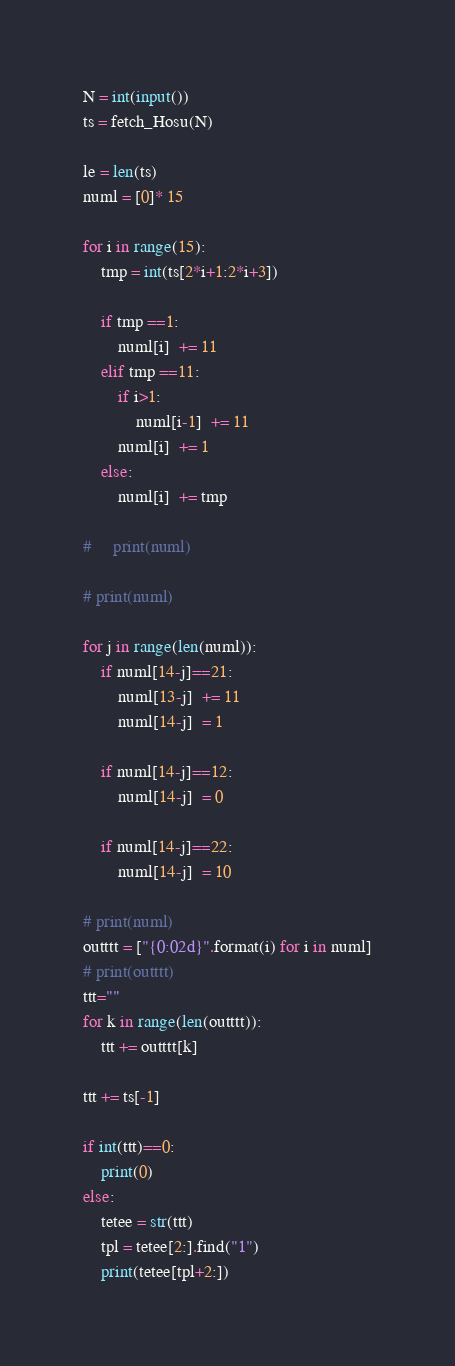<code> <loc_0><loc_0><loc_500><loc_500><_Python_>N = int(input())
ts = fetch_Hosu(N)

le = len(ts)
numl = [0]* 15

for i in range(15):
    tmp = int(ts[2*i+1:2*i+3])
    
    if tmp ==1:
        numl[i]  += 11
    elif tmp ==11:
        if i>1:
            numl[i-1]  += 11
        numl[i]  += 1
    else:
        numl[i]  += tmp
    
#     print(numl)

# print(numl)

for j in range(len(numl)):
    if numl[14-j]==21:
        numl[13-j]  += 11
        numl[14-j]  = 1

    if numl[14-j]==12:
        numl[14-j]  = 0
    
    if numl[14-j]==22:
        numl[14-j]  = 10
    
# print(numl)
outttt = ["{0:02d}".format(i) for i in numl]
# print(outttt)
ttt=""
for k in range(len(outttt)):
    ttt += outttt[k]

ttt += ts[-1]

if int(ttt)==0:
    print(0)
else:
    tetee = str(ttt)
    tpl = tetee[2:].find("1")
    print(tetee[tpl+2:])</code> 